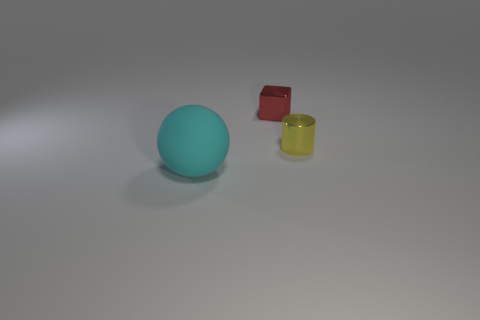Could you tell me something about the lighting in this scene? Certainly! The scene is softly lit with diffused light, creating gentle shadows and a calm atmosphere. There appears to be a single light source coming from above and to the right, as indicated by the shadow direction. 